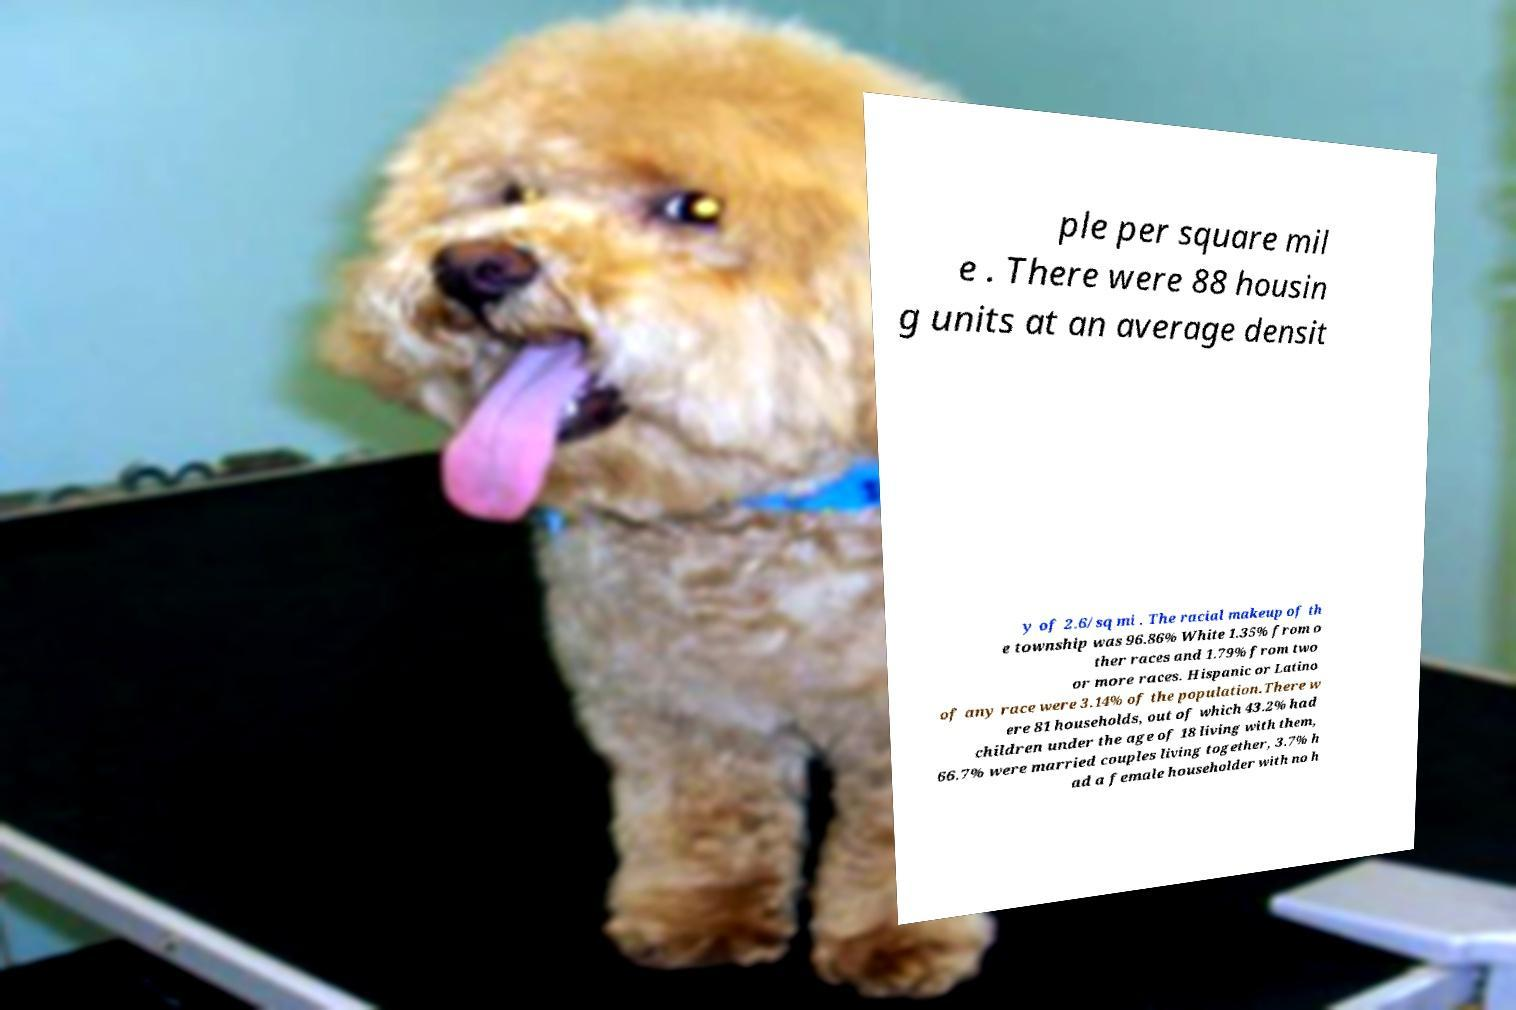Please read and relay the text visible in this image. What does it say? ple per square mil e . There were 88 housin g units at an average densit y of 2.6/sq mi . The racial makeup of th e township was 96.86% White 1.35% from o ther races and 1.79% from two or more races. Hispanic or Latino of any race were 3.14% of the population.There w ere 81 households, out of which 43.2% had children under the age of 18 living with them, 66.7% were married couples living together, 3.7% h ad a female householder with no h 